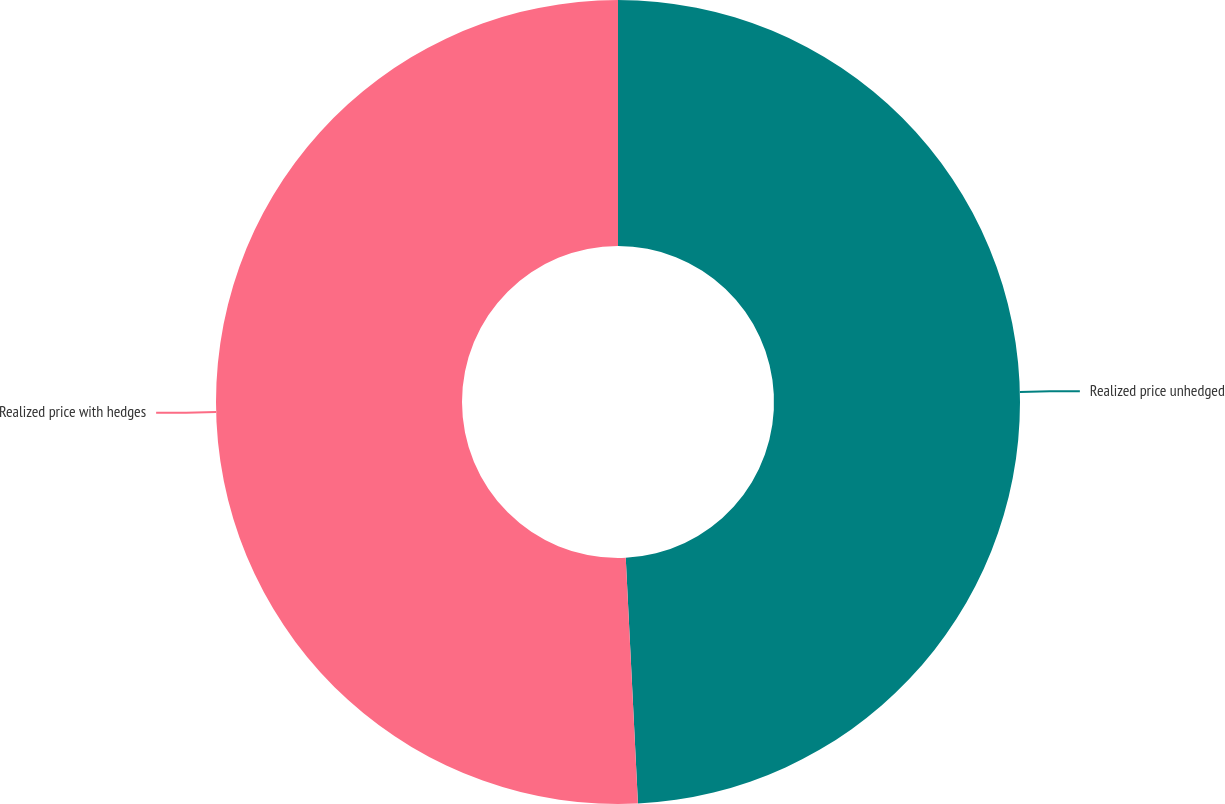Convert chart. <chart><loc_0><loc_0><loc_500><loc_500><pie_chart><fcel>Realized price unhedged<fcel>Realized price with hedges<nl><fcel>49.21%<fcel>50.79%<nl></chart> 